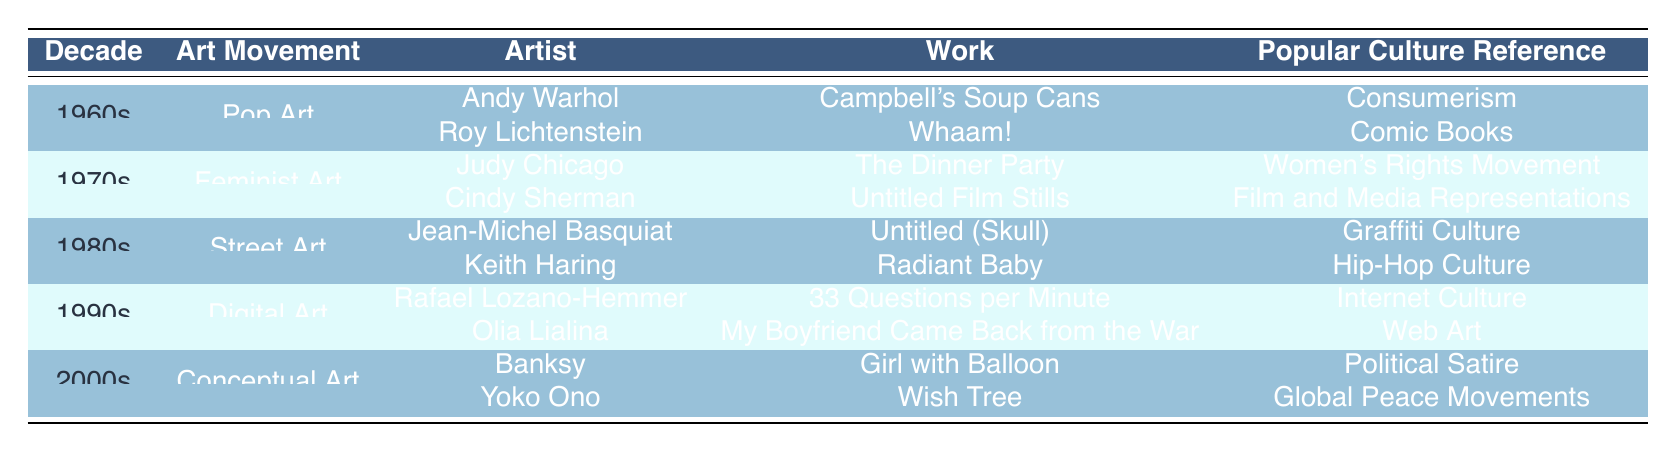What art movement in the 1960s is referenced by consumerism? According to the table, the art movement associated with consumerism in the 1960s is Pop Art. It is explicitly stated in the row under the 1960s column.
Answer: Pop Art Which artist created "The Dinner Party" in the 1970s? The table lists Judy Chicago as the artist who created "The Dinner Party" in the 1970s under the Feminist Art movement.
Answer: Judy Chicago How many artists are listed for the 1980s street art movement? The table shows two artists listed for the Street Art movement in the 1980s: Jean-Michel Basquiat and Keith Haring. Therefore, the count is 2.
Answer: 2 Is "Whaam!" associated with comic books? Yes, according to the table, Roy Lichtenstein's work "Whaam!" references comic books, confirming a true association.
Answer: Yes In which decade did digital art emerge, according to the table? The table indicates that the digital art movement emerged in the 1990s, as stated in the corresponding row under that decade.
Answer: 1990s What are the popular culture references for Judy Chicago and Cindy Sherman? For Judy Chicago, the reference is "Women's Rights Movement" and for Cindy Sherman, it is "Film and Media Representations." These references are identified in their respective rows for the 1970s.
Answer: Women's Rights Movement and Film and Media Representations What is the total number of works mentioned for the 2000s? The table lists 2 works of art created by two artists (Banksy and Yoko Ono) in the 2000s, leading to a total of 2 works.
Answer: 2 Which art movement in the 1980s has a reference to hip-hop culture? The table shows that the Street Art movement in the 1980s includes Keith Haring's work "Radiant Baby," which references hip-hop culture. This can be seen in the specific row detailing his contribution.
Answer: Street Art Which work directly references internet culture in the 1990s? Rafael Lozano-Hemmer's work "33 Questions per Minute" is the one that directly references internet culture, as designated in the table.
Answer: 33 Questions per Minute 